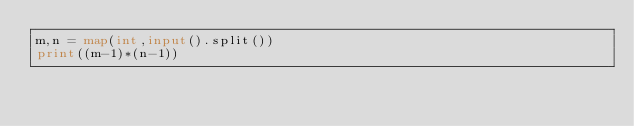<code> <loc_0><loc_0><loc_500><loc_500><_Python_>m,n = map(int,input().split())
print((m-1)*(n-1))</code> 